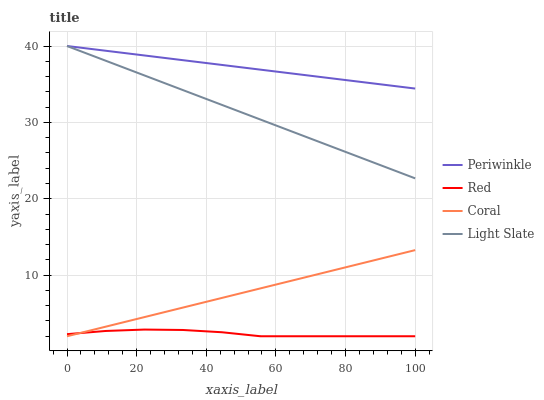Does Red have the minimum area under the curve?
Answer yes or no. Yes. Does Periwinkle have the maximum area under the curve?
Answer yes or no. Yes. Does Coral have the minimum area under the curve?
Answer yes or no. No. Does Coral have the maximum area under the curve?
Answer yes or no. No. Is Coral the smoothest?
Answer yes or no. Yes. Is Red the roughest?
Answer yes or no. Yes. Is Periwinkle the smoothest?
Answer yes or no. No. Is Periwinkle the roughest?
Answer yes or no. No. Does Coral have the lowest value?
Answer yes or no. Yes. Does Periwinkle have the lowest value?
Answer yes or no. No. Does Periwinkle have the highest value?
Answer yes or no. Yes. Does Coral have the highest value?
Answer yes or no. No. Is Red less than Light Slate?
Answer yes or no. Yes. Is Light Slate greater than Red?
Answer yes or no. Yes. Does Light Slate intersect Periwinkle?
Answer yes or no. Yes. Is Light Slate less than Periwinkle?
Answer yes or no. No. Is Light Slate greater than Periwinkle?
Answer yes or no. No. Does Red intersect Light Slate?
Answer yes or no. No. 